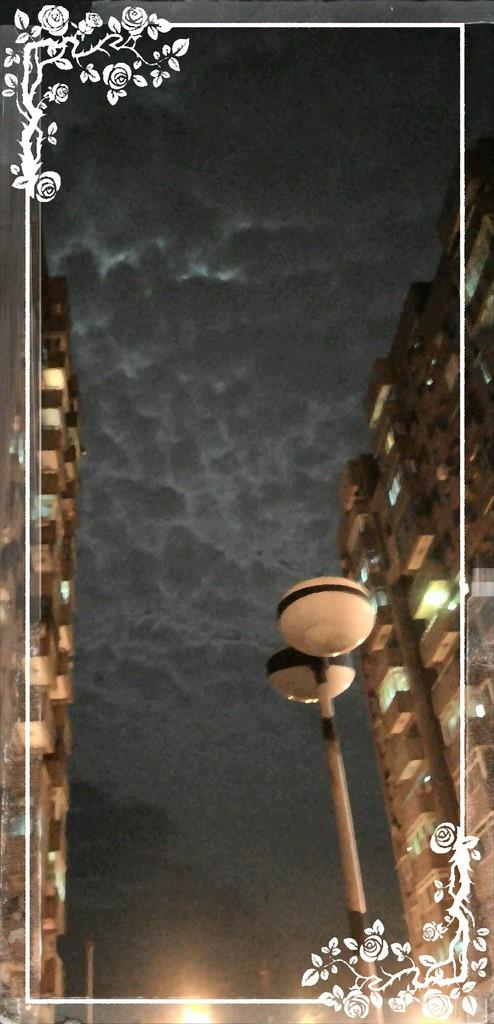What type of picture is the image? The image is an edited picture. What can be seen in the sky in the image? The sky is visible in the image. What type of structures are present in the image? There are buildings in the image. What else can be seen in the image besides the sky and buildings? There are objects in the image. Can you tell me how many mothers are present in the image? There is no mention of a mother or any people in the image, so it cannot be determined if any mothers are present. 